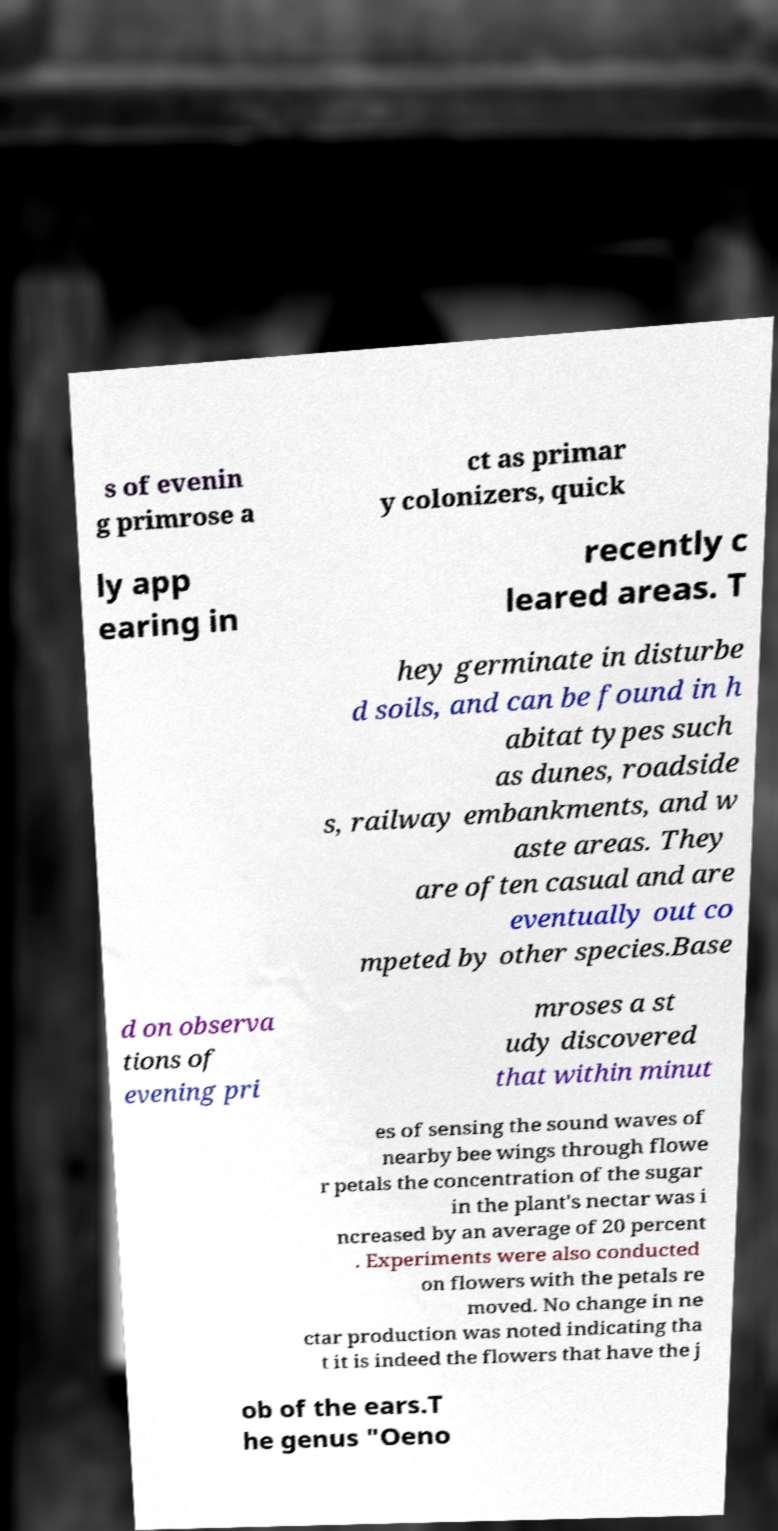Please identify and transcribe the text found in this image. s of evenin g primrose a ct as primar y colonizers, quick ly app earing in recently c leared areas. T hey germinate in disturbe d soils, and can be found in h abitat types such as dunes, roadside s, railway embankments, and w aste areas. They are often casual and are eventually out co mpeted by other species.Base d on observa tions of evening pri mroses a st udy discovered that within minut es of sensing the sound waves of nearby bee wings through flowe r petals the concentration of the sugar in the plant's nectar was i ncreased by an average of 20 percent . Experiments were also conducted on flowers with the petals re moved. No change in ne ctar production was noted indicating tha t it is indeed the flowers that have the j ob of the ears.T he genus "Oeno 